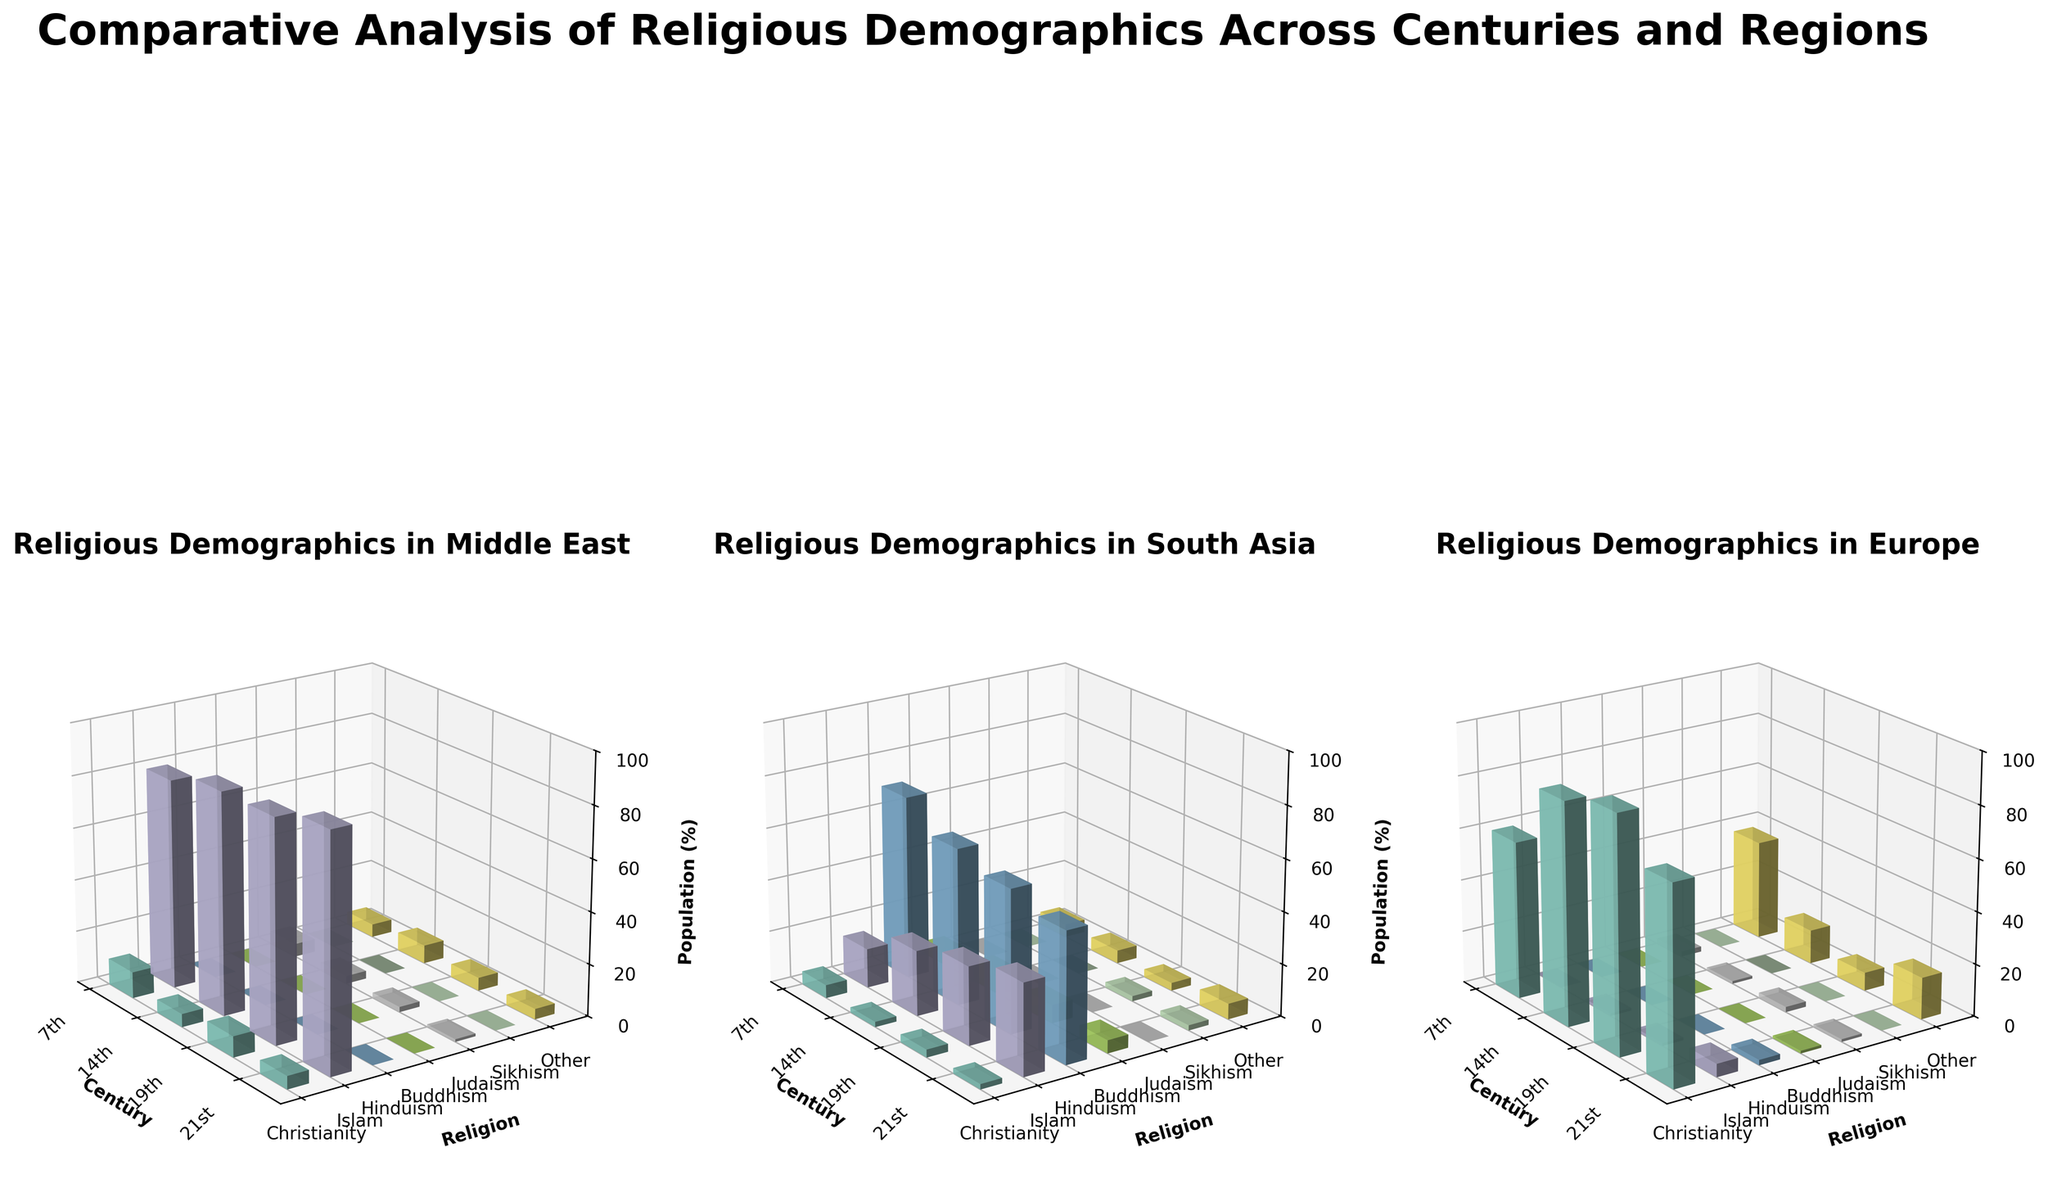Which region had the highest percentage of Christianity in the 14th century? The subplot for Europe in the 14th century shows that Christianity accounted for 85% of the population, which is the highest percentage for Christianity out of all the regions in that century.
Answer: Europe What religion had 0% representation in the Middle East throughout all centuries shown? The subplot for the Middle East shows 0% for Hinduism and Buddhism across the 7th, 14th, 19th, and 21st centuries.
Answer: Hinduism and Buddhism How did the percentage of Islam in South Asia change from the 7th to the 21st century? In the subplot for South Asia, Islam's percentage increased from 15% in the 7th century to 35% in the 21st century.
Answer: Increased from 15% to 35% Between Judaism and Sikhism in the 21st century, which religion had a higher percentage in South Asia? The subplot for South Asia in the 21st century shows Judaism at 0% and Sikhism at 2%. Thus, Sikhism had a higher percentage.
Answer: Sikhism In which century did Europe have the lowest percentage of Christianity, and what was the percentage? The subplot for Europe indicates that the lowest percentage of Christianity (60%) was in the 7th century.
Answer: 7th century, 60% How much did the percentage of Islam in the Middle East change from the 14th to the 21st century? The subplot for the Middle East shows that the percentage of Islam in the 14th century was 85% and increased to 90% in the 21st century. The change is 90% - 85% = 5%.
Answer: Increased by 5% Which region had the most significant decline in the percentage of Buddhism from the 14th to the 21st century? The subplot for South Asia shows Buddhism decreasing from 8% in the 14th century to 5% in the 21st century. The Middle East and Europe had 0% throughout. South Asia had the biggest decline (3%).
Answer: South Asia Compared to the 19th century, what is the difference in percentage points of Hinduism in South Asia in the 21st century? The subplot for South Asia shows Hinduism at 55% in the 19th century and 50% in the 21st century. The difference is 55% - 50% = 5%.
Answer: Decrease of 5% Which religion saw an increase in Europe from the 7th to the 21st century? In the subplot for Europe, the only religion with an increase from the 7th to the 21st century is Islam, which rose from 0% to 5%.
Answer: Islam What percentage of the total religious population in the Middle East in the 21st century is non-Islamic? The subplot for the Middle East in the 21st century shows non-Islamic religions (Christianity 5%, Judaism 1%, Other 4%). The total percentage of non-Islamic religions is 5% + 1% + 4% = 10%.
Answer: 10% 